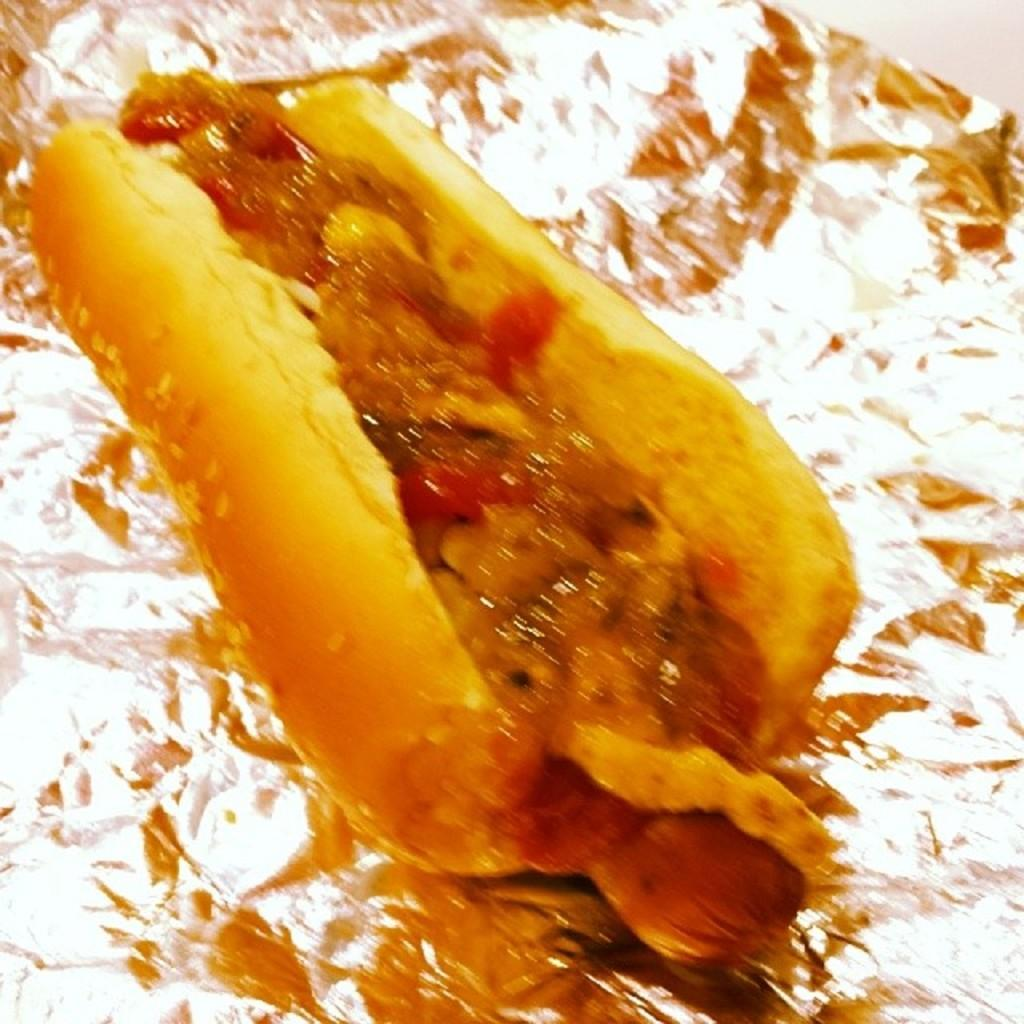What type of food is visible in the image? There is a hot dog in the image. What is the hot dog placed on? The hot dog is on an aluminum foil. What type of bird can be seen sitting on the hot dog in the image? There is no bird present in the image; it only features a hot dog on an aluminum foil. 